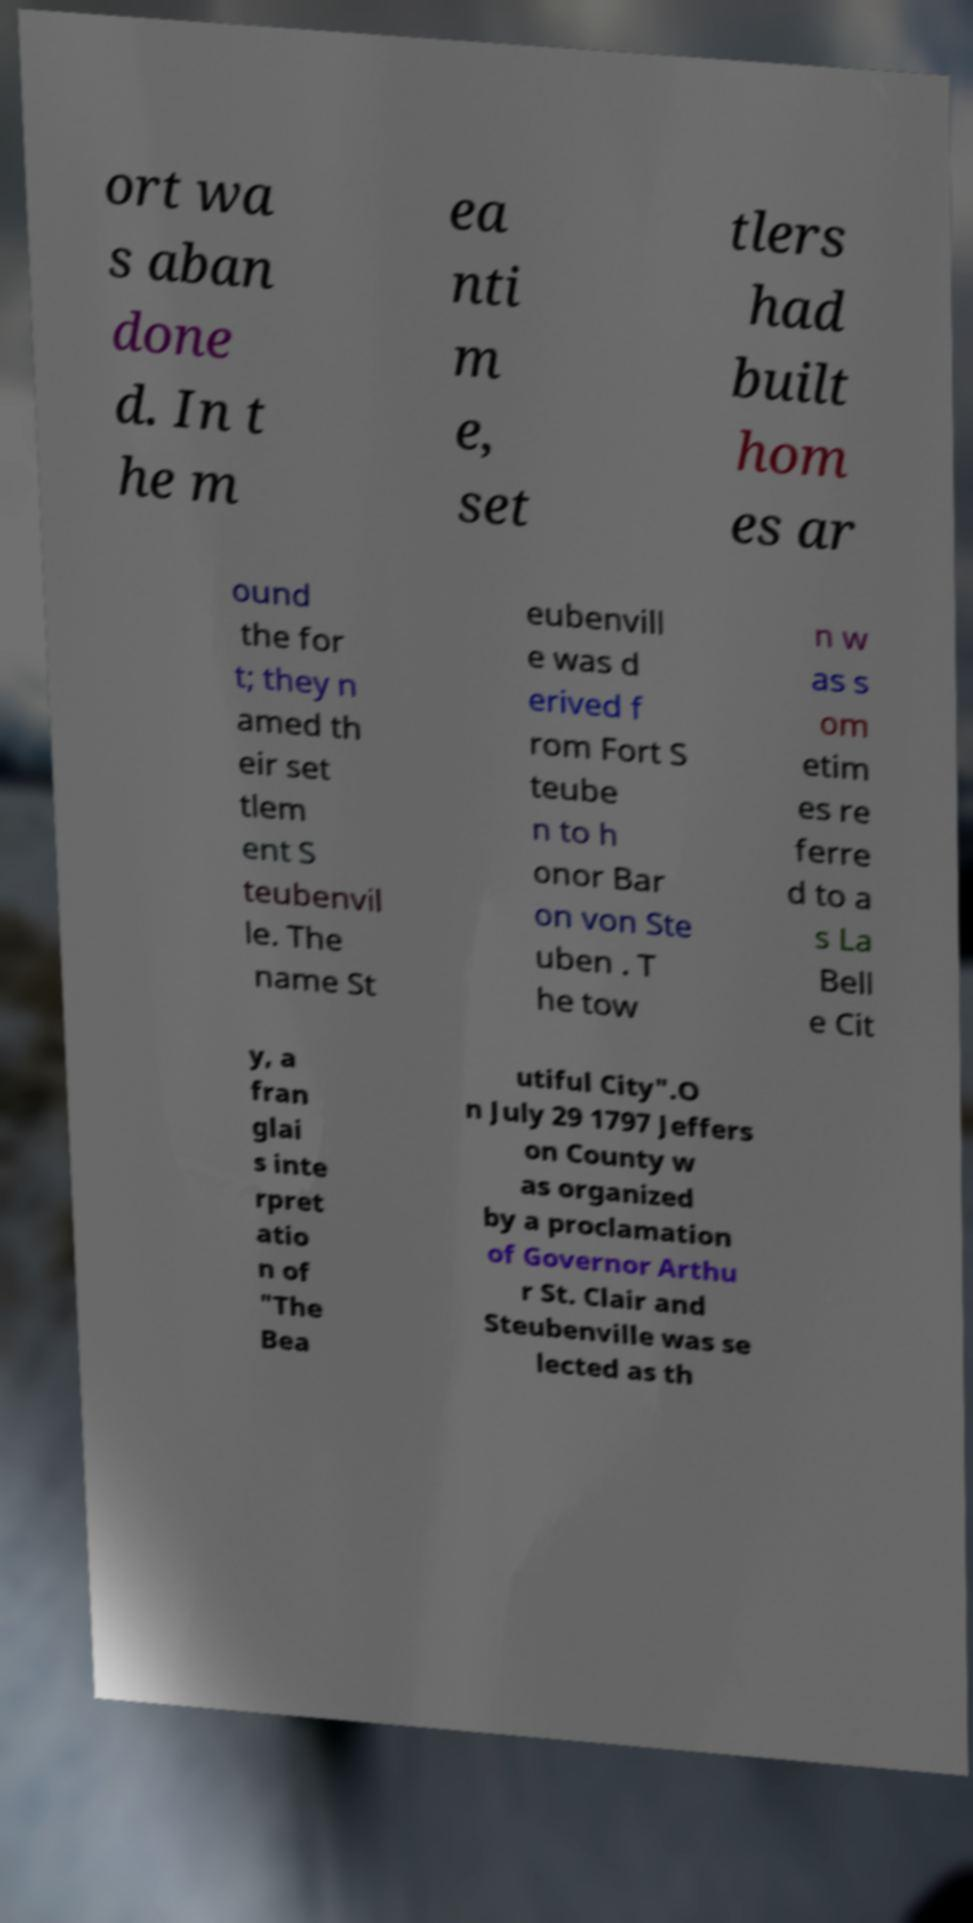Could you assist in decoding the text presented in this image and type it out clearly? ort wa s aban done d. In t he m ea nti m e, set tlers had built hom es ar ound the for t; they n amed th eir set tlem ent S teubenvil le. The name St eubenvill e was d erived f rom Fort S teube n to h onor Bar on von Ste uben . T he tow n w as s om etim es re ferre d to a s La Bell e Cit y, a fran glai s inte rpret atio n of "The Bea utiful City".O n July 29 1797 Jeffers on County w as organized by a proclamation of Governor Arthu r St. Clair and Steubenville was se lected as th 